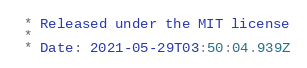<code> <loc_0><loc_0><loc_500><loc_500><_CSS_> * Released under the MIT license
 *
 * Date: 2021-05-29T03:50:04.939Z</code> 